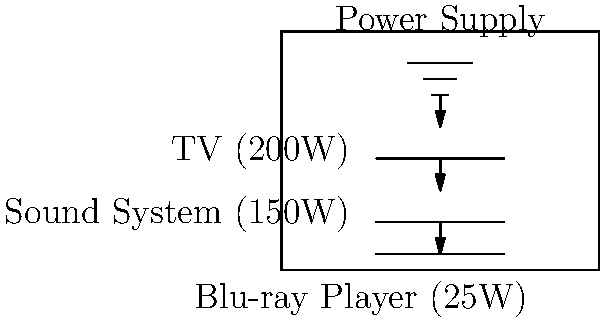As a director collaborating on a women's health project, you're setting up a home theater for a documentary screening. The circuit diagram shows a TV (200W), sound system (150W), and Blu-ray player (25W). If the system operates for 3 hours, what is the total energy consumption in kilowatt-hours (kWh)? To calculate the total energy consumption, we'll follow these steps:

1. Calculate the total power consumption:
   TV: 200W
   Sound System: 150W
   Blu-ray Player: 25W
   Total Power = $200W + 150W + 25W = 375W$

2. Convert watts to kilowatts:
   $375W = 0.375kW$

3. Calculate energy consumption:
   Energy (kWh) = Power (kW) × Time (hours)
   $E = 0.375kW × 3h = 1.125kWh$

Therefore, the total energy consumption for the 3-hour documentary screening is 1.125 kWh.
Answer: 1.125 kWh 